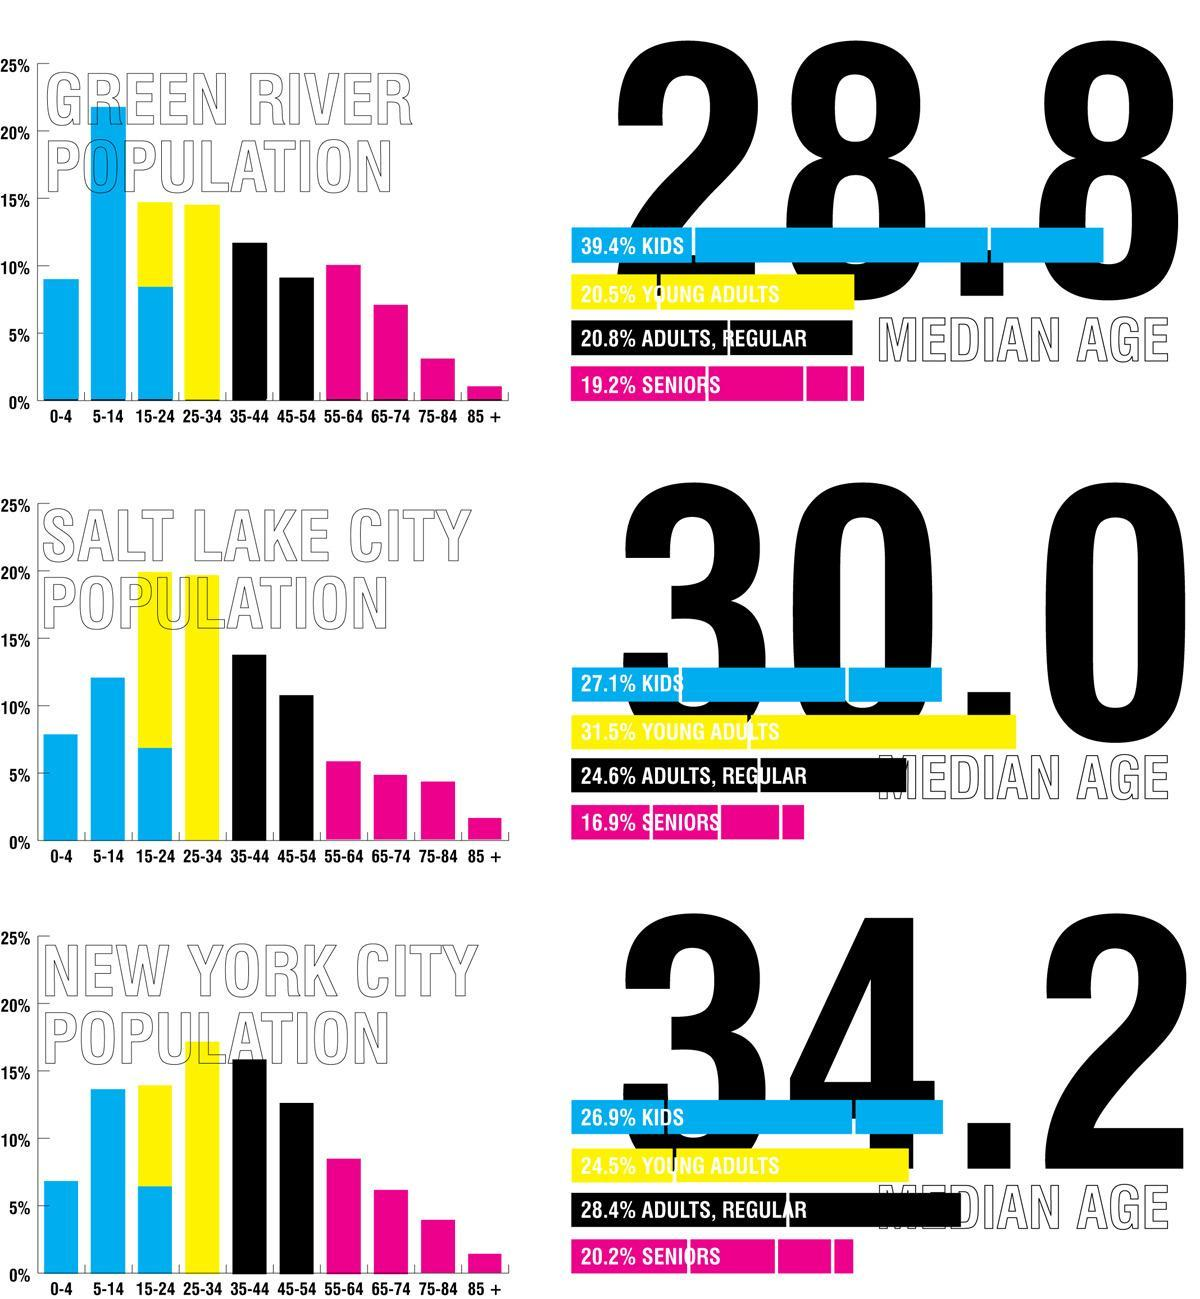What is the percentage of kids and seniors together in Green River?
Answer the question with a short phrase. 58.6% What is the percentage of kids and young adults together in New York City? 51.4% What is the percentage of kids and seniors together in Salt Lake City? 44% What is the percentage of kids and young adults together in Salt Lake City? 58.6% What is the percentage of kids and seniors together in New York City? 47.1% 